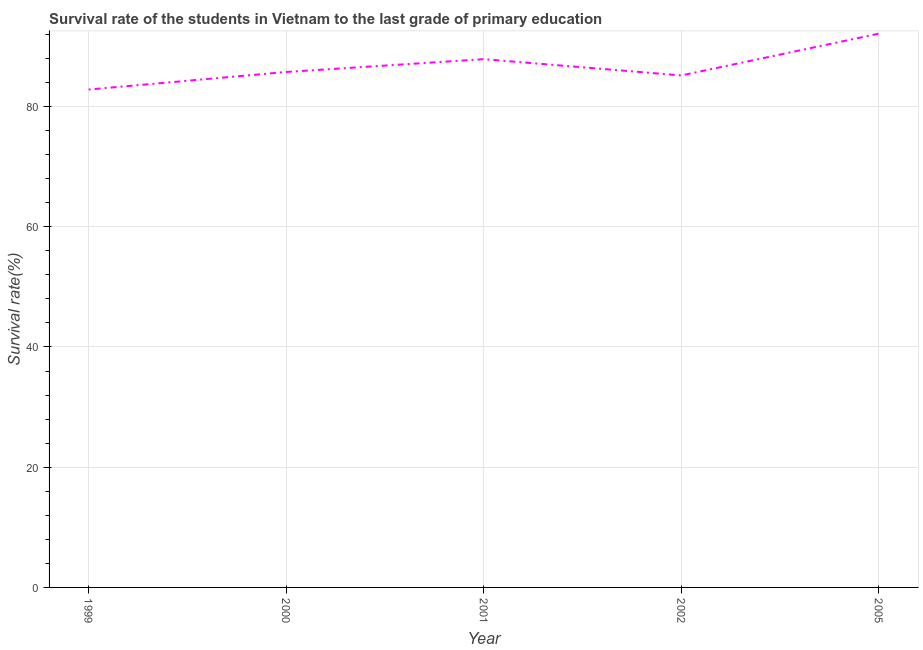What is the survival rate in primary education in 2000?
Offer a very short reply. 85.74. Across all years, what is the maximum survival rate in primary education?
Ensure brevity in your answer.  92.12. Across all years, what is the minimum survival rate in primary education?
Make the answer very short. 82.82. What is the sum of the survival rate in primary education?
Give a very brief answer. 433.72. What is the difference between the survival rate in primary education in 2002 and 2005?
Offer a terse response. -6.96. What is the average survival rate in primary education per year?
Provide a succinct answer. 86.74. What is the median survival rate in primary education?
Your answer should be compact. 85.74. Do a majority of the years between 2001 and 2005 (inclusive) have survival rate in primary education greater than 60 %?
Keep it short and to the point. Yes. What is the ratio of the survival rate in primary education in 2000 to that in 2005?
Provide a short and direct response. 0.93. Is the survival rate in primary education in 1999 less than that in 2001?
Offer a terse response. Yes. What is the difference between the highest and the second highest survival rate in primary education?
Your response must be concise. 4.25. Is the sum of the survival rate in primary education in 1999 and 2001 greater than the maximum survival rate in primary education across all years?
Ensure brevity in your answer.  Yes. What is the difference between the highest and the lowest survival rate in primary education?
Your answer should be very brief. 9.3. In how many years, is the survival rate in primary education greater than the average survival rate in primary education taken over all years?
Offer a very short reply. 2. Does the survival rate in primary education monotonically increase over the years?
Ensure brevity in your answer.  No. How many lines are there?
Offer a very short reply. 1. What is the difference between two consecutive major ticks on the Y-axis?
Ensure brevity in your answer.  20. Are the values on the major ticks of Y-axis written in scientific E-notation?
Your answer should be very brief. No. Does the graph contain grids?
Provide a short and direct response. Yes. What is the title of the graph?
Give a very brief answer. Survival rate of the students in Vietnam to the last grade of primary education. What is the label or title of the Y-axis?
Make the answer very short. Survival rate(%). What is the Survival rate(%) in 1999?
Offer a very short reply. 82.82. What is the Survival rate(%) in 2000?
Your response must be concise. 85.74. What is the Survival rate(%) in 2001?
Give a very brief answer. 87.87. What is the Survival rate(%) of 2002?
Ensure brevity in your answer.  85.17. What is the Survival rate(%) in 2005?
Your answer should be very brief. 92.12. What is the difference between the Survival rate(%) in 1999 and 2000?
Your answer should be very brief. -2.92. What is the difference between the Survival rate(%) in 1999 and 2001?
Your response must be concise. -5.05. What is the difference between the Survival rate(%) in 1999 and 2002?
Provide a succinct answer. -2.35. What is the difference between the Survival rate(%) in 1999 and 2005?
Offer a very short reply. -9.3. What is the difference between the Survival rate(%) in 2000 and 2001?
Make the answer very short. -2.13. What is the difference between the Survival rate(%) in 2000 and 2002?
Your response must be concise. 0.58. What is the difference between the Survival rate(%) in 2000 and 2005?
Keep it short and to the point. -6.38. What is the difference between the Survival rate(%) in 2001 and 2002?
Give a very brief answer. 2.71. What is the difference between the Survival rate(%) in 2001 and 2005?
Your answer should be compact. -4.25. What is the difference between the Survival rate(%) in 2002 and 2005?
Give a very brief answer. -6.96. What is the ratio of the Survival rate(%) in 1999 to that in 2000?
Ensure brevity in your answer.  0.97. What is the ratio of the Survival rate(%) in 1999 to that in 2001?
Provide a succinct answer. 0.94. What is the ratio of the Survival rate(%) in 1999 to that in 2002?
Provide a succinct answer. 0.97. What is the ratio of the Survival rate(%) in 1999 to that in 2005?
Your answer should be compact. 0.9. What is the ratio of the Survival rate(%) in 2001 to that in 2002?
Your answer should be very brief. 1.03. What is the ratio of the Survival rate(%) in 2001 to that in 2005?
Your answer should be compact. 0.95. What is the ratio of the Survival rate(%) in 2002 to that in 2005?
Provide a short and direct response. 0.92. 